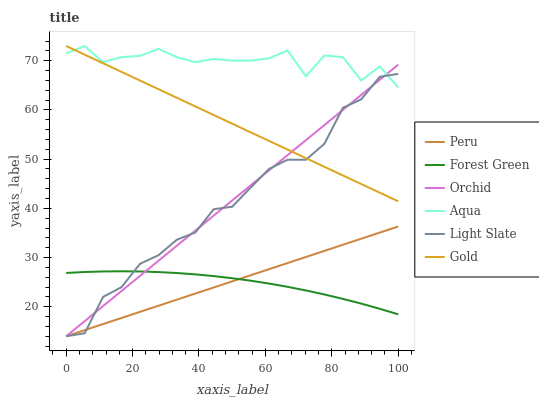Does Forest Green have the minimum area under the curve?
Answer yes or no. Yes. Does Aqua have the maximum area under the curve?
Answer yes or no. Yes. Does Light Slate have the minimum area under the curve?
Answer yes or no. No. Does Light Slate have the maximum area under the curve?
Answer yes or no. No. Is Peru the smoothest?
Answer yes or no. Yes. Is Aqua the roughest?
Answer yes or no. Yes. Is Light Slate the smoothest?
Answer yes or no. No. Is Light Slate the roughest?
Answer yes or no. No. Does Light Slate have the lowest value?
Answer yes or no. Yes. Does Aqua have the lowest value?
Answer yes or no. No. Does Aqua have the highest value?
Answer yes or no. Yes. Does Light Slate have the highest value?
Answer yes or no. No. Is Peru less than Gold?
Answer yes or no. Yes. Is Gold greater than Forest Green?
Answer yes or no. Yes. Does Peru intersect Forest Green?
Answer yes or no. Yes. Is Peru less than Forest Green?
Answer yes or no. No. Is Peru greater than Forest Green?
Answer yes or no. No. Does Peru intersect Gold?
Answer yes or no. No. 